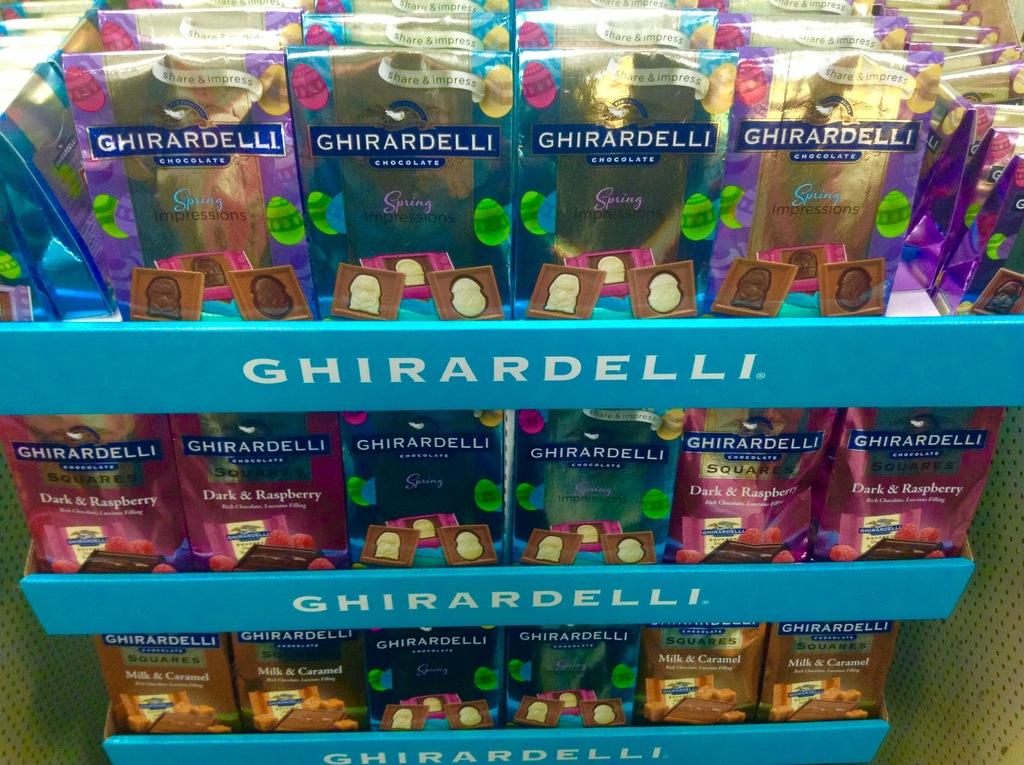What brand of chocolate is this?
Your response must be concise. Ghirardelli. Are there differet types of ghirardelli pictured?
Your answer should be very brief. Yes. 